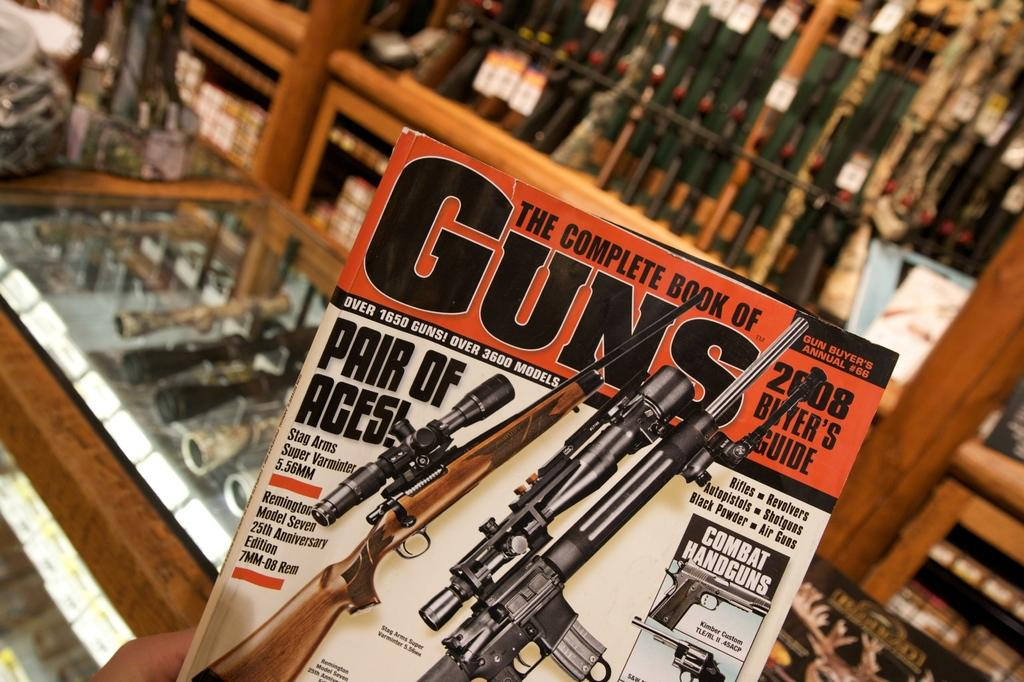<image>
Relay a brief, clear account of the picture shown. The Complete Bookmof Guns 2008 Buyer's Guide is inside a gun shop. 